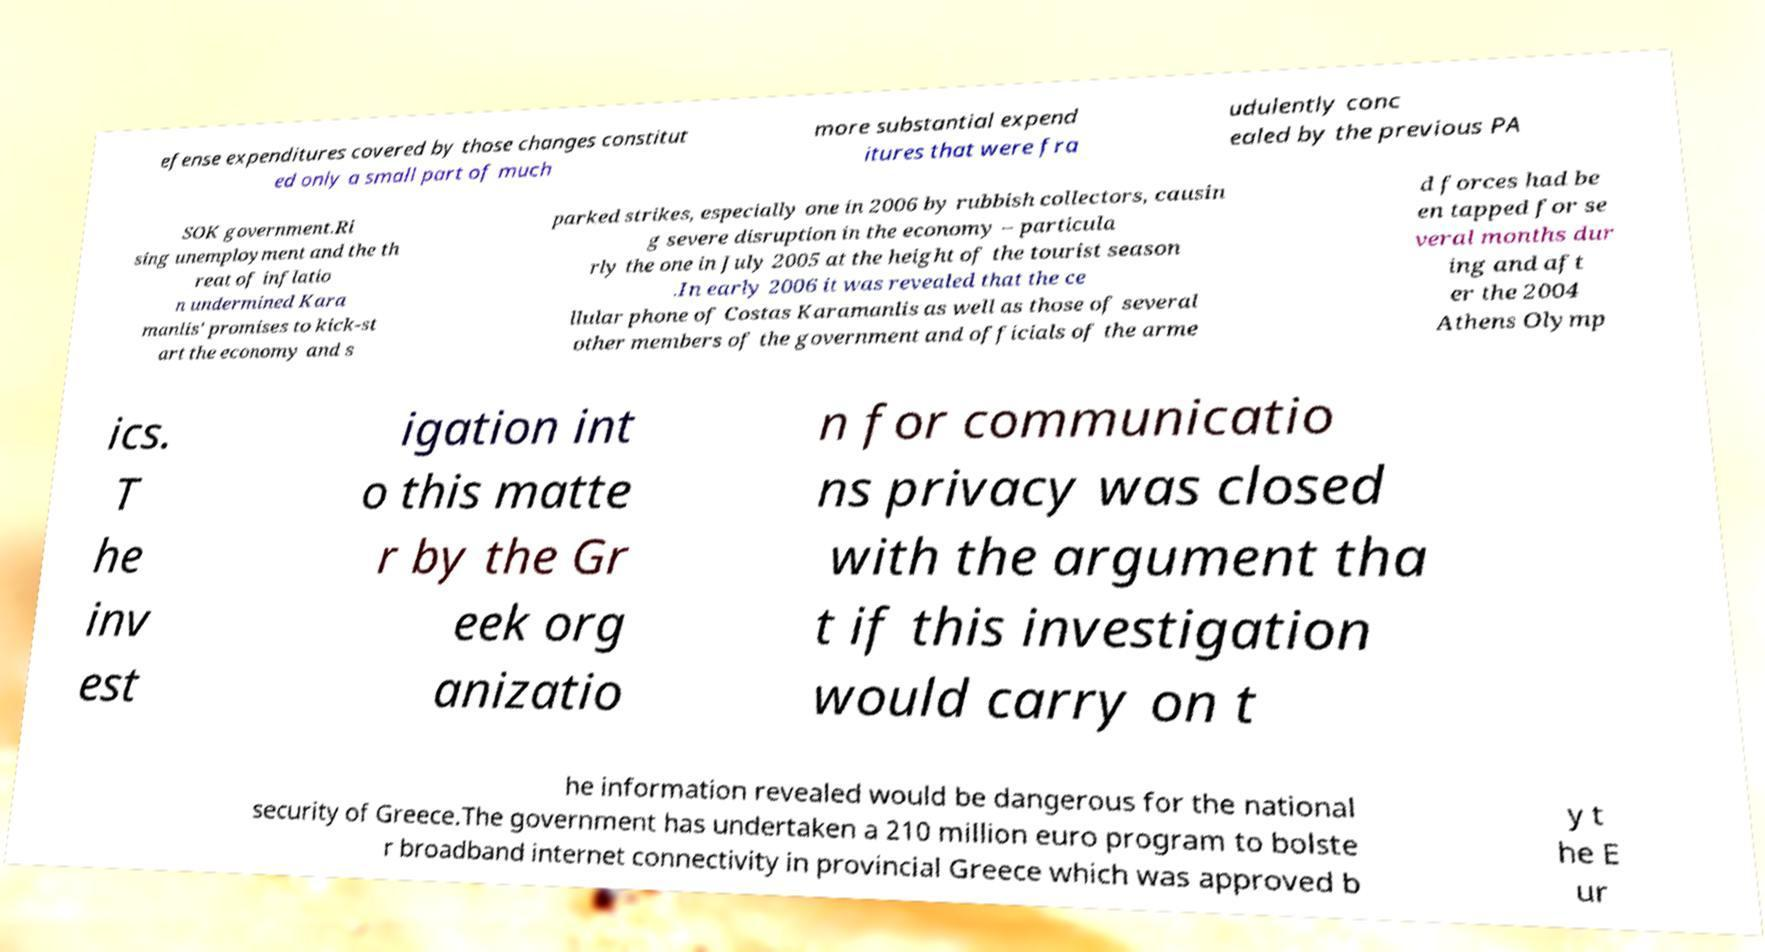Please identify and transcribe the text found in this image. efense expenditures covered by those changes constitut ed only a small part of much more substantial expend itures that were fra udulently conc ealed by the previous PA SOK government.Ri sing unemployment and the th reat of inflatio n undermined Kara manlis' promises to kick-st art the economy and s parked strikes, especially one in 2006 by rubbish collectors, causin g severe disruption in the economy – particula rly the one in July 2005 at the height of the tourist season .In early 2006 it was revealed that the ce llular phone of Costas Karamanlis as well as those of several other members of the government and officials of the arme d forces had be en tapped for se veral months dur ing and aft er the 2004 Athens Olymp ics. T he inv est igation int o this matte r by the Gr eek org anizatio n for communicatio ns privacy was closed with the argument tha t if this investigation would carry on t he information revealed would be dangerous for the national security of Greece.The government has undertaken a 210 million euro program to bolste r broadband internet connectivity in provincial Greece which was approved b y t he E ur 